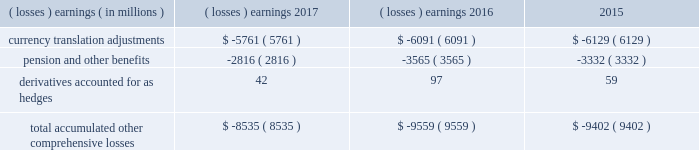Note 17 .
Accumulated other comprehensive losses : pmi's accumulated other comprehensive losses , net of taxes , consisted of the following: .
Reclassifications from other comprehensive earnings the movements in accumulated other comprehensive losses and the related tax impact , for each of the components above , that are due to current period activity and reclassifications to the income statement are shown on the consolidated statements of comprehensive earnings for the years ended december 31 , 2017 , 2016 , and 2015 .
For the years ended december 31 , 2017 , 2016 , and 2015 , $ 2 million , $ ( 5 ) million and $ 1 million of net currency translation adjustment gains/ ( losses ) were transferred from other comprehensive earnings to marketing , administration and research costs in the consolidated statements of earnings , respectively , upon liquidation of subsidiaries .
For additional information , see note 13 .
Benefit plans and note 15 .
Financial instruments for disclosures related to pmi's pension and other benefits and derivative financial instruments .
Note 18 .
Contingencies : tobacco-related litigation legal proceedings covering a wide range of matters are pending or threatened against us , and/or our subsidiaries , and/or our indemnitees in various jurisdictions .
Our indemnitees include distributors , licensees and others that have been named as parties in certain cases and that we have agreed to defend , as well as to pay costs and some or all of judgments , if any , that may be entered against them .
Pursuant to the terms of the distribution agreement between altria group , inc .
( "altria" ) and pmi , pmi will indemnify altria and philip morris usa inc .
( "pm usa" ) , a u.s .
Tobacco subsidiary of altria , for tobacco product claims based in substantial part on products manufactured by pmi or contract manufactured for pmi by pm usa , and pm usa will indemnify pmi for tobacco product claims based in substantial part on products manufactured by pm usa , excluding tobacco products contract manufactured for pmi .
It is possible that there could be adverse developments in pending cases against us and our subsidiaries .
An unfavorable outcome or settlement of pending tobacco-related litigation could encourage the commencement of additional litigation .
Damages claimed in some of the tobacco-related litigation are significant and , in certain cases in brazil , canada and nigeria , range into the billions of u.s .
Dollars .
The variability in pleadings in multiple jurisdictions , together with the actual experience of management in litigating claims , demonstrate that the monetary relief that may be specified in a lawsuit bears little relevance to the ultimate outcome .
Much of the tobacco-related litigation is in its early stages , and litigation is subject to uncertainty .
However , as discussed below , we have to date been largely successful in defending tobacco-related litigation .
We and our subsidiaries record provisions in the consolidated financial statements for pending litigation when we determine that an unfavorable outcome is probable and the amount of the loss can be reasonably estimated .
At the present time , while it is reasonably possible that an unfavorable outcome in a case may occur , after assessing the information available to it ( i ) management has not concluded that it is probable that a loss has been incurred in any of the pending tobacco-related cases ; ( ii ) management is unable to estimate the possible loss or range of loss for any of the pending tobacco-related cases ; and ( iii ) accordingly , no estimated loss has been accrued in the consolidated financial statements for unfavorable outcomes in these cases , if any .
Legal defense costs are expensed as incurred. .
What is the percentage change in total accumulated other comprehensive losses from 2016 to 2017? 
Computations: ((-8535 - -9559) / -9559)
Answer: -0.10712. Note 17 .
Accumulated other comprehensive losses : pmi's accumulated other comprehensive losses , net of taxes , consisted of the following: .
Reclassifications from other comprehensive earnings the movements in accumulated other comprehensive losses and the related tax impact , for each of the components above , that are due to current period activity and reclassifications to the income statement are shown on the consolidated statements of comprehensive earnings for the years ended december 31 , 2017 , 2016 , and 2015 .
For the years ended december 31 , 2017 , 2016 , and 2015 , $ 2 million , $ ( 5 ) million and $ 1 million of net currency translation adjustment gains/ ( losses ) were transferred from other comprehensive earnings to marketing , administration and research costs in the consolidated statements of earnings , respectively , upon liquidation of subsidiaries .
For additional information , see note 13 .
Benefit plans and note 15 .
Financial instruments for disclosures related to pmi's pension and other benefits and derivative financial instruments .
Note 18 .
Contingencies : tobacco-related litigation legal proceedings covering a wide range of matters are pending or threatened against us , and/or our subsidiaries , and/or our indemnitees in various jurisdictions .
Our indemnitees include distributors , licensees and others that have been named as parties in certain cases and that we have agreed to defend , as well as to pay costs and some or all of judgments , if any , that may be entered against them .
Pursuant to the terms of the distribution agreement between altria group , inc .
( "altria" ) and pmi , pmi will indemnify altria and philip morris usa inc .
( "pm usa" ) , a u.s .
Tobacco subsidiary of altria , for tobacco product claims based in substantial part on products manufactured by pmi or contract manufactured for pmi by pm usa , and pm usa will indemnify pmi for tobacco product claims based in substantial part on products manufactured by pm usa , excluding tobacco products contract manufactured for pmi .
It is possible that there could be adverse developments in pending cases against us and our subsidiaries .
An unfavorable outcome or settlement of pending tobacco-related litigation could encourage the commencement of additional litigation .
Damages claimed in some of the tobacco-related litigation are significant and , in certain cases in brazil , canada and nigeria , range into the billions of u.s .
Dollars .
The variability in pleadings in multiple jurisdictions , together with the actual experience of management in litigating claims , demonstrate that the monetary relief that may be specified in a lawsuit bears little relevance to the ultimate outcome .
Much of the tobacco-related litigation is in its early stages , and litigation is subject to uncertainty .
However , as discussed below , we have to date been largely successful in defending tobacco-related litigation .
We and our subsidiaries record provisions in the consolidated financial statements for pending litigation when we determine that an unfavorable outcome is probable and the amount of the loss can be reasonably estimated .
At the present time , while it is reasonably possible that an unfavorable outcome in a case may occur , after assessing the information available to it ( i ) management has not concluded that it is probable that a loss has been incurred in any of the pending tobacco-related cases ; ( ii ) management is unable to estimate the possible loss or range of loss for any of the pending tobacco-related cases ; and ( iii ) accordingly , no estimated loss has been accrued in the consolidated financial statements for unfavorable outcomes in these cases , if any .
Legal defense costs are expensed as incurred. .
What was the change in millions of total accumulated other comprehensive losses from 2015 to 2016? 
Computations: (-9559 - -9402)
Answer: -157.0. 